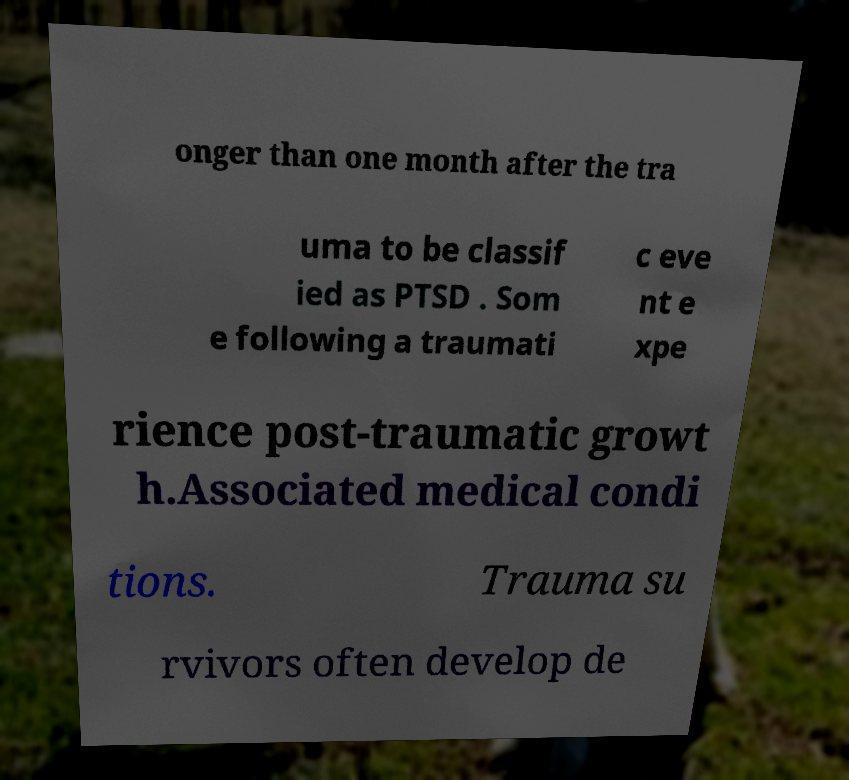For documentation purposes, I need the text within this image transcribed. Could you provide that? onger than one month after the tra uma to be classif ied as PTSD . Som e following a traumati c eve nt e xpe rience post-traumatic growt h.Associated medical condi tions. Trauma su rvivors often develop de 